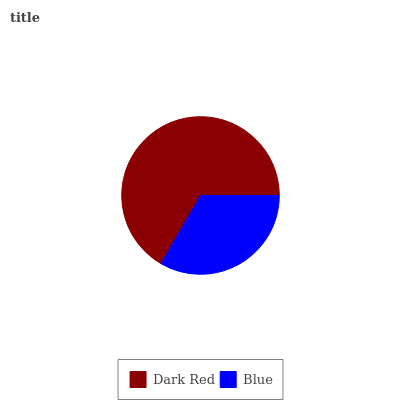Is Blue the minimum?
Answer yes or no. Yes. Is Dark Red the maximum?
Answer yes or no. Yes. Is Blue the maximum?
Answer yes or no. No. Is Dark Red greater than Blue?
Answer yes or no. Yes. Is Blue less than Dark Red?
Answer yes or no. Yes. Is Blue greater than Dark Red?
Answer yes or no. No. Is Dark Red less than Blue?
Answer yes or no. No. Is Dark Red the high median?
Answer yes or no. Yes. Is Blue the low median?
Answer yes or no. Yes. Is Blue the high median?
Answer yes or no. No. Is Dark Red the low median?
Answer yes or no. No. 